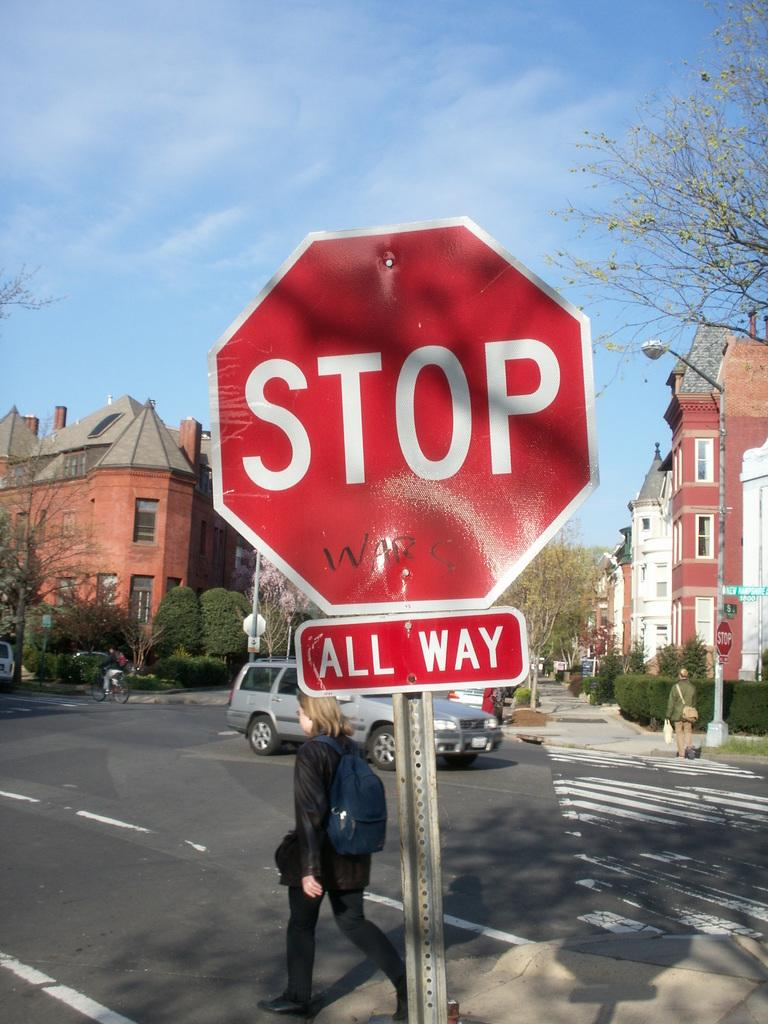<image>
Write a terse but informative summary of the picture. A STOP ALL WAY sign is on the street corner and someone wrote WARS under STOP. 